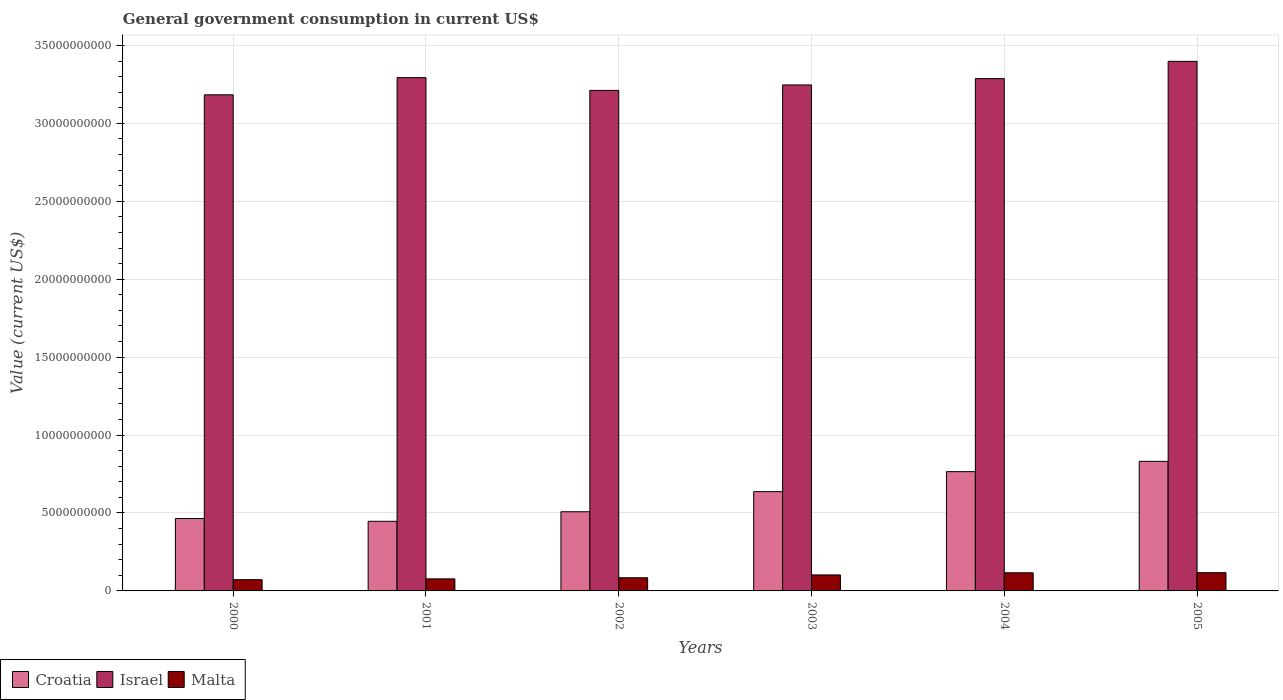How many different coloured bars are there?
Provide a succinct answer. 3. How many groups of bars are there?
Provide a succinct answer. 6. Are the number of bars per tick equal to the number of legend labels?
Your response must be concise. Yes. How many bars are there on the 4th tick from the right?
Keep it short and to the point. 3. What is the label of the 1st group of bars from the left?
Your answer should be very brief. 2000. In how many cases, is the number of bars for a given year not equal to the number of legend labels?
Make the answer very short. 0. What is the government conusmption in Croatia in 2003?
Give a very brief answer. 6.37e+09. Across all years, what is the maximum government conusmption in Malta?
Your response must be concise. 1.17e+09. Across all years, what is the minimum government conusmption in Croatia?
Your answer should be very brief. 4.47e+09. In which year was the government conusmption in Croatia minimum?
Offer a terse response. 2001. What is the total government conusmption in Croatia in the graph?
Your answer should be compact. 3.65e+1. What is the difference between the government conusmption in Malta in 2000 and that in 2004?
Ensure brevity in your answer.  -4.43e+08. What is the difference between the government conusmption in Croatia in 2003 and the government conusmption in Israel in 2004?
Keep it short and to the point. -2.65e+1. What is the average government conusmption in Malta per year?
Your answer should be very brief. 9.50e+08. In the year 2000, what is the difference between the government conusmption in Israel and government conusmption in Croatia?
Offer a terse response. 2.72e+1. What is the ratio of the government conusmption in Malta in 2000 to that in 2005?
Ensure brevity in your answer.  0.62. Is the difference between the government conusmption in Israel in 2003 and 2005 greater than the difference between the government conusmption in Croatia in 2003 and 2005?
Give a very brief answer. Yes. What is the difference between the highest and the second highest government conusmption in Israel?
Keep it short and to the point. 1.04e+09. What is the difference between the highest and the lowest government conusmption in Malta?
Your answer should be compact. 4.50e+08. In how many years, is the government conusmption in Israel greater than the average government conusmption in Israel taken over all years?
Ensure brevity in your answer.  3. What does the 1st bar from the left in 2004 represents?
Provide a succinct answer. Croatia. What does the 3rd bar from the right in 2005 represents?
Offer a very short reply. Croatia. How many bars are there?
Provide a short and direct response. 18. Are all the bars in the graph horizontal?
Make the answer very short. No. How many years are there in the graph?
Provide a succinct answer. 6. What is the difference between two consecutive major ticks on the Y-axis?
Give a very brief answer. 5.00e+09. Are the values on the major ticks of Y-axis written in scientific E-notation?
Your response must be concise. No. Does the graph contain grids?
Provide a succinct answer. Yes. How many legend labels are there?
Make the answer very short. 3. How are the legend labels stacked?
Keep it short and to the point. Horizontal. What is the title of the graph?
Offer a terse response. General government consumption in current US$. What is the label or title of the X-axis?
Offer a very short reply. Years. What is the label or title of the Y-axis?
Make the answer very short. Value (current US$). What is the Value (current US$) of Croatia in 2000?
Your answer should be very brief. 4.65e+09. What is the Value (current US$) in Israel in 2000?
Provide a short and direct response. 3.18e+1. What is the Value (current US$) of Malta in 2000?
Offer a terse response. 7.21e+08. What is the Value (current US$) in Croatia in 2001?
Your answer should be very brief. 4.47e+09. What is the Value (current US$) of Israel in 2001?
Offer a terse response. 3.29e+1. What is the Value (current US$) in Malta in 2001?
Offer a very short reply. 7.72e+08. What is the Value (current US$) of Croatia in 2002?
Give a very brief answer. 5.08e+09. What is the Value (current US$) of Israel in 2002?
Your answer should be very brief. 3.21e+1. What is the Value (current US$) in Malta in 2002?
Make the answer very short. 8.44e+08. What is the Value (current US$) of Croatia in 2003?
Your answer should be very brief. 6.37e+09. What is the Value (current US$) in Israel in 2003?
Make the answer very short. 3.25e+1. What is the Value (current US$) of Malta in 2003?
Keep it short and to the point. 1.03e+09. What is the Value (current US$) in Croatia in 2004?
Offer a terse response. 7.65e+09. What is the Value (current US$) of Israel in 2004?
Give a very brief answer. 3.29e+1. What is the Value (current US$) in Malta in 2004?
Provide a short and direct response. 1.16e+09. What is the Value (current US$) in Croatia in 2005?
Make the answer very short. 8.32e+09. What is the Value (current US$) in Israel in 2005?
Provide a succinct answer. 3.40e+1. What is the Value (current US$) of Malta in 2005?
Offer a terse response. 1.17e+09. Across all years, what is the maximum Value (current US$) in Croatia?
Give a very brief answer. 8.32e+09. Across all years, what is the maximum Value (current US$) of Israel?
Your answer should be very brief. 3.40e+1. Across all years, what is the maximum Value (current US$) in Malta?
Give a very brief answer. 1.17e+09. Across all years, what is the minimum Value (current US$) in Croatia?
Make the answer very short. 4.47e+09. Across all years, what is the minimum Value (current US$) of Israel?
Give a very brief answer. 3.18e+1. Across all years, what is the minimum Value (current US$) in Malta?
Offer a terse response. 7.21e+08. What is the total Value (current US$) in Croatia in the graph?
Keep it short and to the point. 3.65e+1. What is the total Value (current US$) of Israel in the graph?
Offer a terse response. 1.96e+11. What is the total Value (current US$) in Malta in the graph?
Offer a terse response. 5.70e+09. What is the difference between the Value (current US$) in Croatia in 2000 and that in 2001?
Offer a terse response. 1.78e+08. What is the difference between the Value (current US$) of Israel in 2000 and that in 2001?
Provide a short and direct response. -1.10e+09. What is the difference between the Value (current US$) of Malta in 2000 and that in 2001?
Provide a short and direct response. -5.16e+07. What is the difference between the Value (current US$) in Croatia in 2000 and that in 2002?
Offer a terse response. -4.35e+08. What is the difference between the Value (current US$) in Israel in 2000 and that in 2002?
Your answer should be very brief. -2.84e+08. What is the difference between the Value (current US$) of Malta in 2000 and that in 2002?
Provide a succinct answer. -1.24e+08. What is the difference between the Value (current US$) in Croatia in 2000 and that in 2003?
Keep it short and to the point. -1.72e+09. What is the difference between the Value (current US$) in Israel in 2000 and that in 2003?
Provide a short and direct response. -6.34e+08. What is the difference between the Value (current US$) in Malta in 2000 and that in 2003?
Provide a succinct answer. -3.05e+08. What is the difference between the Value (current US$) of Croatia in 2000 and that in 2004?
Keep it short and to the point. -3.01e+09. What is the difference between the Value (current US$) in Israel in 2000 and that in 2004?
Provide a succinct answer. -1.04e+09. What is the difference between the Value (current US$) in Malta in 2000 and that in 2004?
Make the answer very short. -4.43e+08. What is the difference between the Value (current US$) of Croatia in 2000 and that in 2005?
Provide a short and direct response. -3.67e+09. What is the difference between the Value (current US$) in Israel in 2000 and that in 2005?
Keep it short and to the point. -2.15e+09. What is the difference between the Value (current US$) of Malta in 2000 and that in 2005?
Your response must be concise. -4.50e+08. What is the difference between the Value (current US$) in Croatia in 2001 and that in 2002?
Provide a succinct answer. -6.14e+08. What is the difference between the Value (current US$) of Israel in 2001 and that in 2002?
Keep it short and to the point. 8.19e+08. What is the difference between the Value (current US$) of Malta in 2001 and that in 2002?
Offer a very short reply. -7.21e+07. What is the difference between the Value (current US$) of Croatia in 2001 and that in 2003?
Give a very brief answer. -1.90e+09. What is the difference between the Value (current US$) of Israel in 2001 and that in 2003?
Make the answer very short. 4.69e+08. What is the difference between the Value (current US$) in Malta in 2001 and that in 2003?
Offer a terse response. -2.53e+08. What is the difference between the Value (current US$) of Croatia in 2001 and that in 2004?
Your answer should be very brief. -3.19e+09. What is the difference between the Value (current US$) of Israel in 2001 and that in 2004?
Offer a terse response. 6.41e+07. What is the difference between the Value (current US$) of Malta in 2001 and that in 2004?
Your response must be concise. -3.92e+08. What is the difference between the Value (current US$) of Croatia in 2001 and that in 2005?
Offer a terse response. -3.85e+09. What is the difference between the Value (current US$) of Israel in 2001 and that in 2005?
Make the answer very short. -1.04e+09. What is the difference between the Value (current US$) in Malta in 2001 and that in 2005?
Offer a very short reply. -3.98e+08. What is the difference between the Value (current US$) of Croatia in 2002 and that in 2003?
Keep it short and to the point. -1.29e+09. What is the difference between the Value (current US$) of Israel in 2002 and that in 2003?
Your answer should be very brief. -3.50e+08. What is the difference between the Value (current US$) of Malta in 2002 and that in 2003?
Your answer should be very brief. -1.81e+08. What is the difference between the Value (current US$) in Croatia in 2002 and that in 2004?
Make the answer very short. -2.57e+09. What is the difference between the Value (current US$) of Israel in 2002 and that in 2004?
Give a very brief answer. -7.55e+08. What is the difference between the Value (current US$) of Malta in 2002 and that in 2004?
Make the answer very short. -3.19e+08. What is the difference between the Value (current US$) of Croatia in 2002 and that in 2005?
Your answer should be very brief. -3.23e+09. What is the difference between the Value (current US$) in Israel in 2002 and that in 2005?
Keep it short and to the point. -1.86e+09. What is the difference between the Value (current US$) in Malta in 2002 and that in 2005?
Offer a very short reply. -3.26e+08. What is the difference between the Value (current US$) of Croatia in 2003 and that in 2004?
Offer a very short reply. -1.28e+09. What is the difference between the Value (current US$) in Israel in 2003 and that in 2004?
Give a very brief answer. -4.05e+08. What is the difference between the Value (current US$) of Malta in 2003 and that in 2004?
Provide a succinct answer. -1.38e+08. What is the difference between the Value (current US$) in Croatia in 2003 and that in 2005?
Provide a short and direct response. -1.95e+09. What is the difference between the Value (current US$) of Israel in 2003 and that in 2005?
Your answer should be compact. -1.51e+09. What is the difference between the Value (current US$) in Malta in 2003 and that in 2005?
Offer a very short reply. -1.45e+08. What is the difference between the Value (current US$) of Croatia in 2004 and that in 2005?
Ensure brevity in your answer.  -6.62e+08. What is the difference between the Value (current US$) in Israel in 2004 and that in 2005?
Your response must be concise. -1.11e+09. What is the difference between the Value (current US$) in Malta in 2004 and that in 2005?
Your answer should be very brief. -6.87e+06. What is the difference between the Value (current US$) in Croatia in 2000 and the Value (current US$) in Israel in 2001?
Provide a succinct answer. -2.83e+1. What is the difference between the Value (current US$) in Croatia in 2000 and the Value (current US$) in Malta in 2001?
Your response must be concise. 3.87e+09. What is the difference between the Value (current US$) of Israel in 2000 and the Value (current US$) of Malta in 2001?
Give a very brief answer. 3.11e+1. What is the difference between the Value (current US$) of Croatia in 2000 and the Value (current US$) of Israel in 2002?
Keep it short and to the point. -2.75e+1. What is the difference between the Value (current US$) of Croatia in 2000 and the Value (current US$) of Malta in 2002?
Ensure brevity in your answer.  3.80e+09. What is the difference between the Value (current US$) of Israel in 2000 and the Value (current US$) of Malta in 2002?
Your response must be concise. 3.10e+1. What is the difference between the Value (current US$) of Croatia in 2000 and the Value (current US$) of Israel in 2003?
Your response must be concise. -2.78e+1. What is the difference between the Value (current US$) in Croatia in 2000 and the Value (current US$) in Malta in 2003?
Your response must be concise. 3.62e+09. What is the difference between the Value (current US$) in Israel in 2000 and the Value (current US$) in Malta in 2003?
Provide a short and direct response. 3.08e+1. What is the difference between the Value (current US$) in Croatia in 2000 and the Value (current US$) in Israel in 2004?
Provide a short and direct response. -2.82e+1. What is the difference between the Value (current US$) of Croatia in 2000 and the Value (current US$) of Malta in 2004?
Offer a very short reply. 3.48e+09. What is the difference between the Value (current US$) in Israel in 2000 and the Value (current US$) in Malta in 2004?
Your answer should be compact. 3.07e+1. What is the difference between the Value (current US$) of Croatia in 2000 and the Value (current US$) of Israel in 2005?
Your answer should be very brief. -2.93e+1. What is the difference between the Value (current US$) of Croatia in 2000 and the Value (current US$) of Malta in 2005?
Offer a very short reply. 3.47e+09. What is the difference between the Value (current US$) of Israel in 2000 and the Value (current US$) of Malta in 2005?
Give a very brief answer. 3.07e+1. What is the difference between the Value (current US$) in Croatia in 2001 and the Value (current US$) in Israel in 2002?
Make the answer very short. -2.76e+1. What is the difference between the Value (current US$) in Croatia in 2001 and the Value (current US$) in Malta in 2002?
Ensure brevity in your answer.  3.62e+09. What is the difference between the Value (current US$) of Israel in 2001 and the Value (current US$) of Malta in 2002?
Keep it short and to the point. 3.21e+1. What is the difference between the Value (current US$) in Croatia in 2001 and the Value (current US$) in Israel in 2003?
Provide a succinct answer. -2.80e+1. What is the difference between the Value (current US$) in Croatia in 2001 and the Value (current US$) in Malta in 2003?
Ensure brevity in your answer.  3.44e+09. What is the difference between the Value (current US$) of Israel in 2001 and the Value (current US$) of Malta in 2003?
Offer a terse response. 3.19e+1. What is the difference between the Value (current US$) in Croatia in 2001 and the Value (current US$) in Israel in 2004?
Your response must be concise. -2.84e+1. What is the difference between the Value (current US$) in Croatia in 2001 and the Value (current US$) in Malta in 2004?
Your answer should be very brief. 3.30e+09. What is the difference between the Value (current US$) in Israel in 2001 and the Value (current US$) in Malta in 2004?
Provide a succinct answer. 3.18e+1. What is the difference between the Value (current US$) of Croatia in 2001 and the Value (current US$) of Israel in 2005?
Offer a very short reply. -2.95e+1. What is the difference between the Value (current US$) of Croatia in 2001 and the Value (current US$) of Malta in 2005?
Offer a very short reply. 3.30e+09. What is the difference between the Value (current US$) of Israel in 2001 and the Value (current US$) of Malta in 2005?
Provide a short and direct response. 3.18e+1. What is the difference between the Value (current US$) of Croatia in 2002 and the Value (current US$) of Israel in 2003?
Keep it short and to the point. -2.74e+1. What is the difference between the Value (current US$) of Croatia in 2002 and the Value (current US$) of Malta in 2003?
Provide a succinct answer. 4.06e+09. What is the difference between the Value (current US$) of Israel in 2002 and the Value (current US$) of Malta in 2003?
Offer a terse response. 3.11e+1. What is the difference between the Value (current US$) of Croatia in 2002 and the Value (current US$) of Israel in 2004?
Make the answer very short. -2.78e+1. What is the difference between the Value (current US$) in Croatia in 2002 and the Value (current US$) in Malta in 2004?
Your answer should be very brief. 3.92e+09. What is the difference between the Value (current US$) of Israel in 2002 and the Value (current US$) of Malta in 2004?
Ensure brevity in your answer.  3.10e+1. What is the difference between the Value (current US$) in Croatia in 2002 and the Value (current US$) in Israel in 2005?
Offer a very short reply. -2.89e+1. What is the difference between the Value (current US$) in Croatia in 2002 and the Value (current US$) in Malta in 2005?
Your response must be concise. 3.91e+09. What is the difference between the Value (current US$) in Israel in 2002 and the Value (current US$) in Malta in 2005?
Your answer should be very brief. 3.09e+1. What is the difference between the Value (current US$) in Croatia in 2003 and the Value (current US$) in Israel in 2004?
Offer a very short reply. -2.65e+1. What is the difference between the Value (current US$) of Croatia in 2003 and the Value (current US$) of Malta in 2004?
Ensure brevity in your answer.  5.21e+09. What is the difference between the Value (current US$) in Israel in 2003 and the Value (current US$) in Malta in 2004?
Make the answer very short. 3.13e+1. What is the difference between the Value (current US$) of Croatia in 2003 and the Value (current US$) of Israel in 2005?
Keep it short and to the point. -2.76e+1. What is the difference between the Value (current US$) of Croatia in 2003 and the Value (current US$) of Malta in 2005?
Offer a very short reply. 5.20e+09. What is the difference between the Value (current US$) of Israel in 2003 and the Value (current US$) of Malta in 2005?
Make the answer very short. 3.13e+1. What is the difference between the Value (current US$) in Croatia in 2004 and the Value (current US$) in Israel in 2005?
Provide a short and direct response. -2.63e+1. What is the difference between the Value (current US$) in Croatia in 2004 and the Value (current US$) in Malta in 2005?
Provide a short and direct response. 6.48e+09. What is the difference between the Value (current US$) of Israel in 2004 and the Value (current US$) of Malta in 2005?
Your response must be concise. 3.17e+1. What is the average Value (current US$) in Croatia per year?
Make the answer very short. 6.09e+09. What is the average Value (current US$) in Israel per year?
Keep it short and to the point. 3.27e+1. What is the average Value (current US$) in Malta per year?
Provide a succinct answer. 9.50e+08. In the year 2000, what is the difference between the Value (current US$) in Croatia and Value (current US$) in Israel?
Offer a very short reply. -2.72e+1. In the year 2000, what is the difference between the Value (current US$) in Croatia and Value (current US$) in Malta?
Offer a terse response. 3.92e+09. In the year 2000, what is the difference between the Value (current US$) in Israel and Value (current US$) in Malta?
Offer a very short reply. 3.11e+1. In the year 2001, what is the difference between the Value (current US$) of Croatia and Value (current US$) of Israel?
Offer a terse response. -2.85e+1. In the year 2001, what is the difference between the Value (current US$) in Croatia and Value (current US$) in Malta?
Give a very brief answer. 3.69e+09. In the year 2001, what is the difference between the Value (current US$) of Israel and Value (current US$) of Malta?
Your response must be concise. 3.22e+1. In the year 2002, what is the difference between the Value (current US$) of Croatia and Value (current US$) of Israel?
Provide a short and direct response. -2.70e+1. In the year 2002, what is the difference between the Value (current US$) in Croatia and Value (current US$) in Malta?
Provide a succinct answer. 4.24e+09. In the year 2002, what is the difference between the Value (current US$) in Israel and Value (current US$) in Malta?
Offer a terse response. 3.13e+1. In the year 2003, what is the difference between the Value (current US$) in Croatia and Value (current US$) in Israel?
Provide a succinct answer. -2.61e+1. In the year 2003, what is the difference between the Value (current US$) of Croatia and Value (current US$) of Malta?
Your response must be concise. 5.34e+09. In the year 2003, what is the difference between the Value (current US$) of Israel and Value (current US$) of Malta?
Offer a very short reply. 3.14e+1. In the year 2004, what is the difference between the Value (current US$) in Croatia and Value (current US$) in Israel?
Offer a very short reply. -2.52e+1. In the year 2004, what is the difference between the Value (current US$) in Croatia and Value (current US$) in Malta?
Your answer should be very brief. 6.49e+09. In the year 2004, what is the difference between the Value (current US$) in Israel and Value (current US$) in Malta?
Offer a terse response. 3.17e+1. In the year 2005, what is the difference between the Value (current US$) of Croatia and Value (current US$) of Israel?
Your answer should be very brief. -2.57e+1. In the year 2005, what is the difference between the Value (current US$) of Croatia and Value (current US$) of Malta?
Make the answer very short. 7.14e+09. In the year 2005, what is the difference between the Value (current US$) in Israel and Value (current US$) in Malta?
Your answer should be very brief. 3.28e+1. What is the ratio of the Value (current US$) of Croatia in 2000 to that in 2001?
Provide a short and direct response. 1.04. What is the ratio of the Value (current US$) in Israel in 2000 to that in 2001?
Provide a succinct answer. 0.97. What is the ratio of the Value (current US$) of Malta in 2000 to that in 2001?
Provide a succinct answer. 0.93. What is the ratio of the Value (current US$) in Croatia in 2000 to that in 2002?
Make the answer very short. 0.91. What is the ratio of the Value (current US$) of Malta in 2000 to that in 2002?
Give a very brief answer. 0.85. What is the ratio of the Value (current US$) in Croatia in 2000 to that in 2003?
Ensure brevity in your answer.  0.73. What is the ratio of the Value (current US$) of Israel in 2000 to that in 2003?
Provide a succinct answer. 0.98. What is the ratio of the Value (current US$) in Malta in 2000 to that in 2003?
Provide a succinct answer. 0.7. What is the ratio of the Value (current US$) of Croatia in 2000 to that in 2004?
Your response must be concise. 0.61. What is the ratio of the Value (current US$) in Israel in 2000 to that in 2004?
Provide a short and direct response. 0.97. What is the ratio of the Value (current US$) in Malta in 2000 to that in 2004?
Offer a very short reply. 0.62. What is the ratio of the Value (current US$) in Croatia in 2000 to that in 2005?
Keep it short and to the point. 0.56. What is the ratio of the Value (current US$) of Israel in 2000 to that in 2005?
Make the answer very short. 0.94. What is the ratio of the Value (current US$) of Malta in 2000 to that in 2005?
Provide a short and direct response. 0.62. What is the ratio of the Value (current US$) of Croatia in 2001 to that in 2002?
Provide a short and direct response. 0.88. What is the ratio of the Value (current US$) of Israel in 2001 to that in 2002?
Your answer should be compact. 1.03. What is the ratio of the Value (current US$) of Malta in 2001 to that in 2002?
Your answer should be compact. 0.91. What is the ratio of the Value (current US$) in Croatia in 2001 to that in 2003?
Give a very brief answer. 0.7. What is the ratio of the Value (current US$) in Israel in 2001 to that in 2003?
Offer a terse response. 1.01. What is the ratio of the Value (current US$) of Malta in 2001 to that in 2003?
Provide a short and direct response. 0.75. What is the ratio of the Value (current US$) in Croatia in 2001 to that in 2004?
Your answer should be compact. 0.58. What is the ratio of the Value (current US$) of Malta in 2001 to that in 2004?
Keep it short and to the point. 0.66. What is the ratio of the Value (current US$) of Croatia in 2001 to that in 2005?
Your answer should be compact. 0.54. What is the ratio of the Value (current US$) in Israel in 2001 to that in 2005?
Offer a very short reply. 0.97. What is the ratio of the Value (current US$) in Malta in 2001 to that in 2005?
Your response must be concise. 0.66. What is the ratio of the Value (current US$) in Croatia in 2002 to that in 2003?
Offer a terse response. 0.8. What is the ratio of the Value (current US$) in Israel in 2002 to that in 2003?
Make the answer very short. 0.99. What is the ratio of the Value (current US$) of Malta in 2002 to that in 2003?
Your response must be concise. 0.82. What is the ratio of the Value (current US$) in Croatia in 2002 to that in 2004?
Give a very brief answer. 0.66. What is the ratio of the Value (current US$) of Israel in 2002 to that in 2004?
Your response must be concise. 0.98. What is the ratio of the Value (current US$) in Malta in 2002 to that in 2004?
Keep it short and to the point. 0.73. What is the ratio of the Value (current US$) of Croatia in 2002 to that in 2005?
Offer a very short reply. 0.61. What is the ratio of the Value (current US$) of Israel in 2002 to that in 2005?
Ensure brevity in your answer.  0.95. What is the ratio of the Value (current US$) of Malta in 2002 to that in 2005?
Your answer should be very brief. 0.72. What is the ratio of the Value (current US$) in Croatia in 2003 to that in 2004?
Give a very brief answer. 0.83. What is the ratio of the Value (current US$) of Malta in 2003 to that in 2004?
Keep it short and to the point. 0.88. What is the ratio of the Value (current US$) in Croatia in 2003 to that in 2005?
Your answer should be very brief. 0.77. What is the ratio of the Value (current US$) of Israel in 2003 to that in 2005?
Your answer should be very brief. 0.96. What is the ratio of the Value (current US$) in Malta in 2003 to that in 2005?
Your answer should be compact. 0.88. What is the ratio of the Value (current US$) of Croatia in 2004 to that in 2005?
Your response must be concise. 0.92. What is the ratio of the Value (current US$) in Israel in 2004 to that in 2005?
Offer a very short reply. 0.97. What is the difference between the highest and the second highest Value (current US$) in Croatia?
Keep it short and to the point. 6.62e+08. What is the difference between the highest and the second highest Value (current US$) in Israel?
Make the answer very short. 1.04e+09. What is the difference between the highest and the second highest Value (current US$) in Malta?
Your answer should be very brief. 6.87e+06. What is the difference between the highest and the lowest Value (current US$) in Croatia?
Ensure brevity in your answer.  3.85e+09. What is the difference between the highest and the lowest Value (current US$) of Israel?
Provide a short and direct response. 2.15e+09. What is the difference between the highest and the lowest Value (current US$) in Malta?
Make the answer very short. 4.50e+08. 